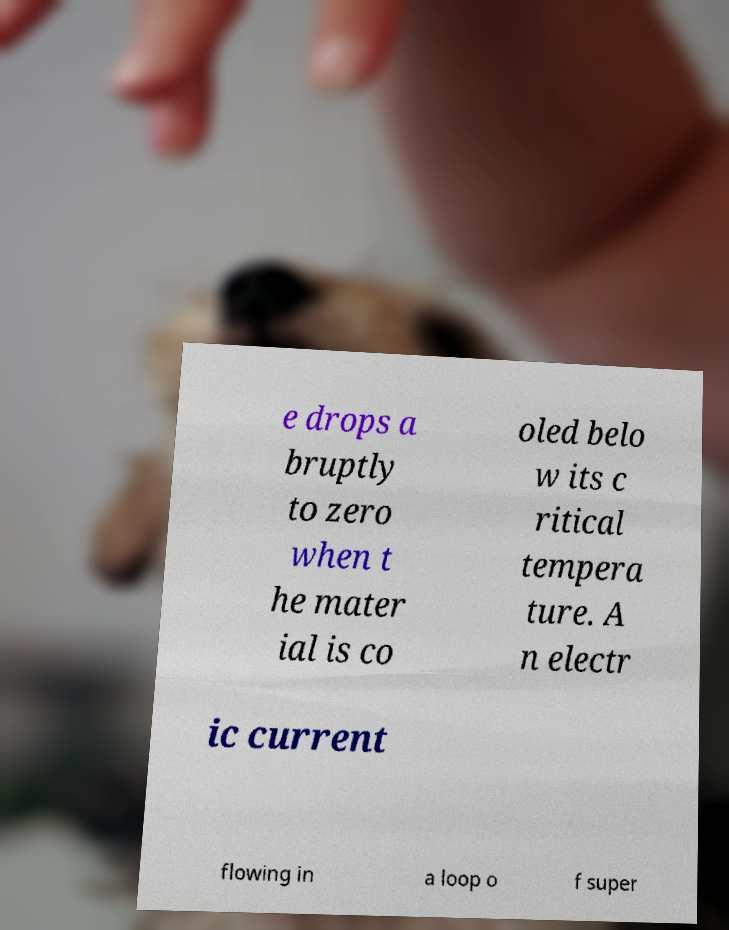Please identify and transcribe the text found in this image. e drops a bruptly to zero when t he mater ial is co oled belo w its c ritical tempera ture. A n electr ic current flowing in a loop o f super 